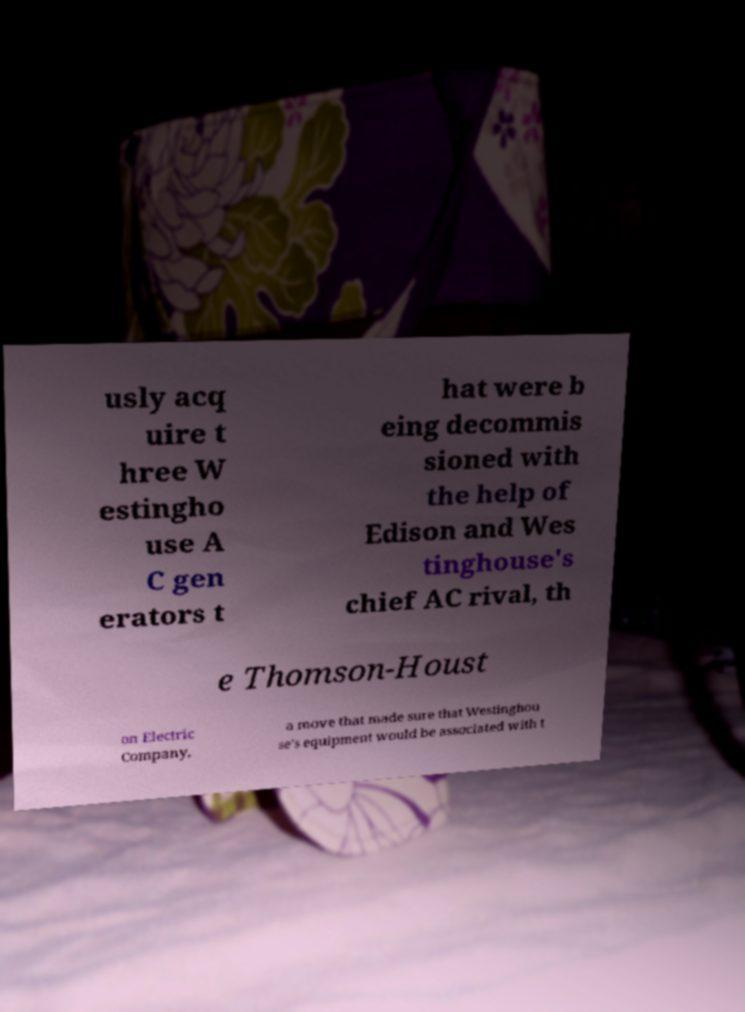Please read and relay the text visible in this image. What does it say? usly acq uire t hree W estingho use A C gen erators t hat were b eing decommis sioned with the help of Edison and Wes tinghouse's chief AC rival, th e Thomson-Houst on Electric Company, a move that made sure that Westinghou se's equipment would be associated with t 